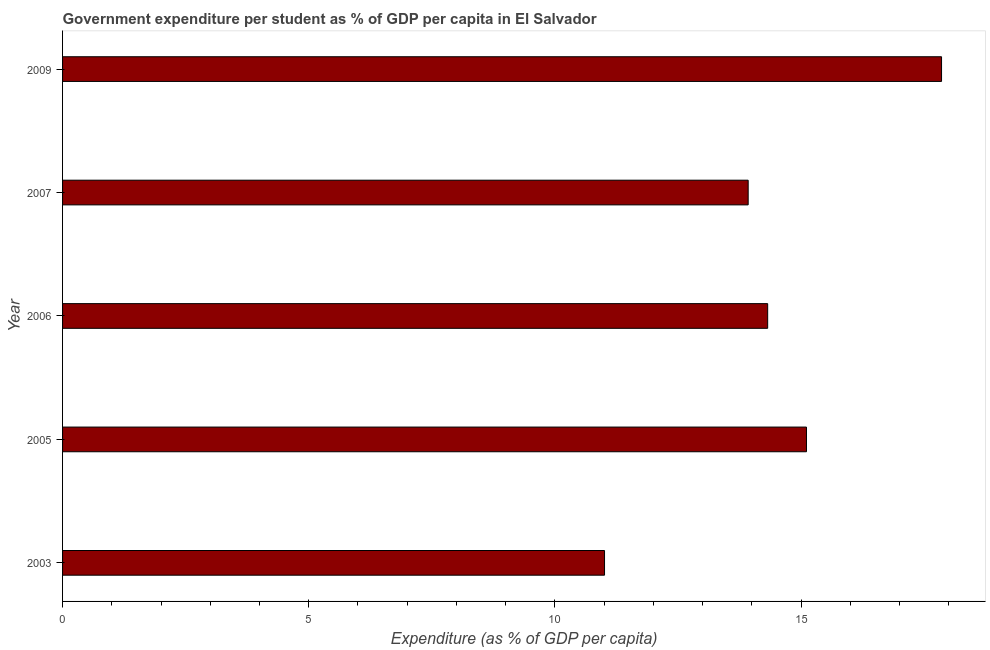Does the graph contain any zero values?
Provide a short and direct response. No. What is the title of the graph?
Provide a succinct answer. Government expenditure per student as % of GDP per capita in El Salvador. What is the label or title of the X-axis?
Make the answer very short. Expenditure (as % of GDP per capita). What is the label or title of the Y-axis?
Your answer should be very brief. Year. What is the government expenditure per student in 2003?
Make the answer very short. 11.01. Across all years, what is the maximum government expenditure per student?
Provide a succinct answer. 17.85. Across all years, what is the minimum government expenditure per student?
Provide a succinct answer. 11.01. In which year was the government expenditure per student maximum?
Keep it short and to the point. 2009. In which year was the government expenditure per student minimum?
Provide a short and direct response. 2003. What is the sum of the government expenditure per student?
Ensure brevity in your answer.  72.22. What is the difference between the government expenditure per student in 2005 and 2009?
Give a very brief answer. -2.74. What is the average government expenditure per student per year?
Give a very brief answer. 14.45. What is the median government expenditure per student?
Keep it short and to the point. 14.32. What is the ratio of the government expenditure per student in 2003 to that in 2007?
Provide a short and direct response. 0.79. Is the government expenditure per student in 2003 less than that in 2007?
Offer a terse response. Yes. Is the difference between the government expenditure per student in 2003 and 2006 greater than the difference between any two years?
Keep it short and to the point. No. What is the difference between the highest and the second highest government expenditure per student?
Keep it short and to the point. 2.74. What is the difference between the highest and the lowest government expenditure per student?
Offer a terse response. 6.85. In how many years, is the government expenditure per student greater than the average government expenditure per student taken over all years?
Offer a terse response. 2. How many years are there in the graph?
Provide a succinct answer. 5. What is the difference between two consecutive major ticks on the X-axis?
Make the answer very short. 5. What is the Expenditure (as % of GDP per capita) in 2003?
Your response must be concise. 11.01. What is the Expenditure (as % of GDP per capita) of 2005?
Your answer should be compact. 15.11. What is the Expenditure (as % of GDP per capita) in 2006?
Your answer should be compact. 14.32. What is the Expenditure (as % of GDP per capita) of 2007?
Provide a succinct answer. 13.93. What is the Expenditure (as % of GDP per capita) in 2009?
Offer a very short reply. 17.85. What is the difference between the Expenditure (as % of GDP per capita) in 2003 and 2005?
Provide a short and direct response. -4.1. What is the difference between the Expenditure (as % of GDP per capita) in 2003 and 2006?
Make the answer very short. -3.31. What is the difference between the Expenditure (as % of GDP per capita) in 2003 and 2007?
Provide a short and direct response. -2.92. What is the difference between the Expenditure (as % of GDP per capita) in 2003 and 2009?
Give a very brief answer. -6.85. What is the difference between the Expenditure (as % of GDP per capita) in 2005 and 2006?
Offer a very short reply. 0.79. What is the difference between the Expenditure (as % of GDP per capita) in 2005 and 2007?
Give a very brief answer. 1.18. What is the difference between the Expenditure (as % of GDP per capita) in 2005 and 2009?
Keep it short and to the point. -2.74. What is the difference between the Expenditure (as % of GDP per capita) in 2006 and 2007?
Make the answer very short. 0.4. What is the difference between the Expenditure (as % of GDP per capita) in 2006 and 2009?
Give a very brief answer. -3.53. What is the difference between the Expenditure (as % of GDP per capita) in 2007 and 2009?
Your answer should be compact. -3.93. What is the ratio of the Expenditure (as % of GDP per capita) in 2003 to that in 2005?
Keep it short and to the point. 0.73. What is the ratio of the Expenditure (as % of GDP per capita) in 2003 to that in 2006?
Give a very brief answer. 0.77. What is the ratio of the Expenditure (as % of GDP per capita) in 2003 to that in 2007?
Ensure brevity in your answer.  0.79. What is the ratio of the Expenditure (as % of GDP per capita) in 2003 to that in 2009?
Ensure brevity in your answer.  0.62. What is the ratio of the Expenditure (as % of GDP per capita) in 2005 to that in 2006?
Provide a short and direct response. 1.05. What is the ratio of the Expenditure (as % of GDP per capita) in 2005 to that in 2007?
Your answer should be very brief. 1.08. What is the ratio of the Expenditure (as % of GDP per capita) in 2005 to that in 2009?
Provide a succinct answer. 0.85. What is the ratio of the Expenditure (as % of GDP per capita) in 2006 to that in 2007?
Offer a very short reply. 1.03. What is the ratio of the Expenditure (as % of GDP per capita) in 2006 to that in 2009?
Make the answer very short. 0.8. What is the ratio of the Expenditure (as % of GDP per capita) in 2007 to that in 2009?
Offer a very short reply. 0.78. 